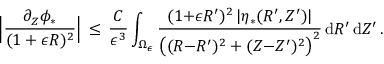Convert formula to latex. <formula><loc_0><loc_0><loc_500><loc_500>\left | \frac { \partial _ { Z } \phi _ { * } } { ( 1 + \epsilon R ) ^ { 2 } } \right | \, \leq \, \frac { C } { \epsilon ^ { 3 } } \int _ { \Omega _ { \epsilon } } \frac { ( 1 { + } \epsilon R ^ { \prime } ) ^ { 2 } \, | \eta _ { * } ( R ^ { \prime } , Z ^ { \prime } ) | } { \left ( ( R { - } R ^ { \prime } ) ^ { 2 } + ( Z { - } Z ^ { \prime } ) ^ { 2 } \right ) ^ { 2 } } \, d R ^ { \prime } \, d Z ^ { \prime } \, .</formula> 